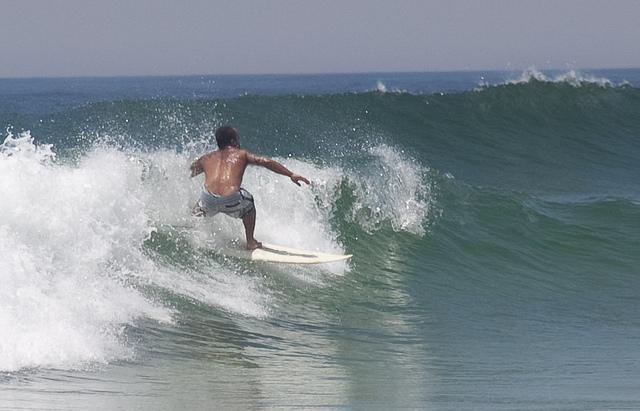How many people are in the background?
Give a very brief answer. 0. 